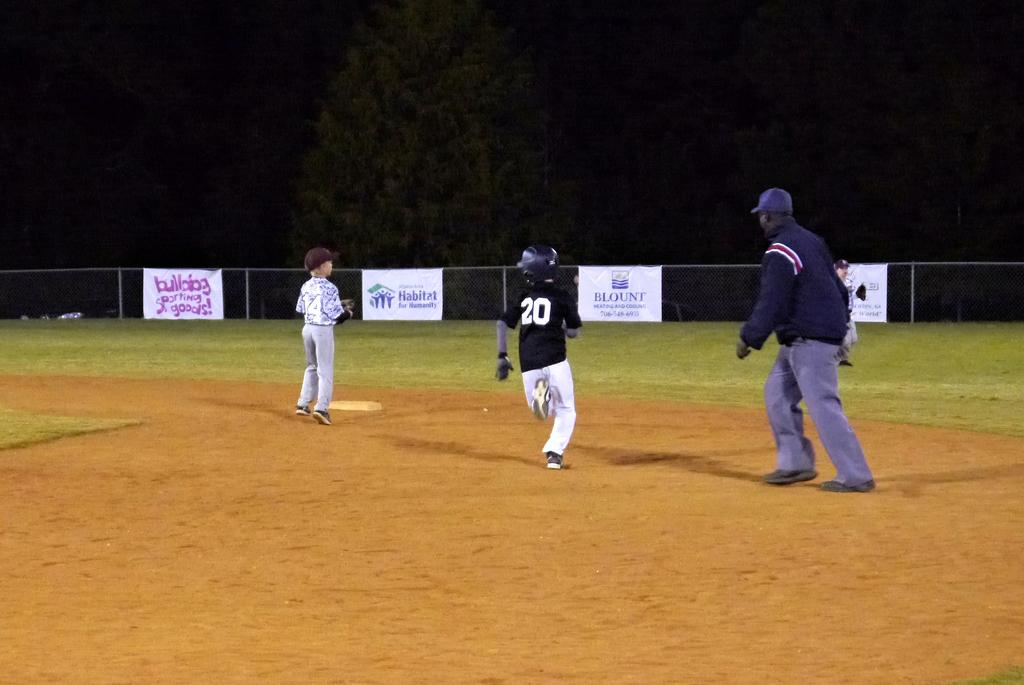<image>
Render a clear and concise summary of the photo. Baseball game that has sponsor cards on the fence that reads Habitat for Humanity in blue lettering. 